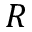<formula> <loc_0><loc_0><loc_500><loc_500>R</formula> 